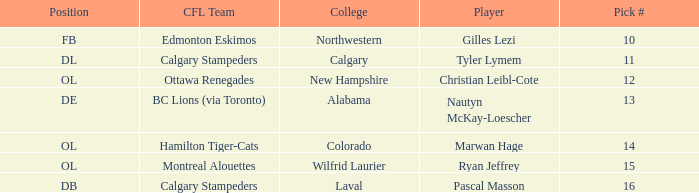Which player from the 2004 CFL draft attended Wilfrid Laurier? Ryan Jeffrey. 